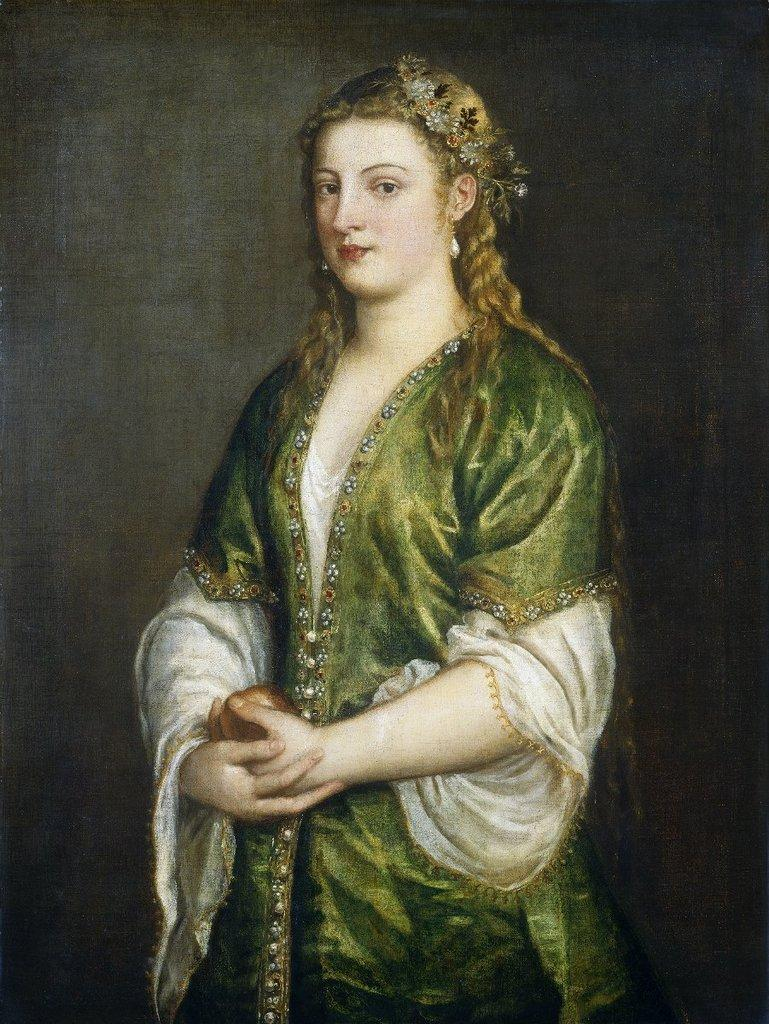What is the main subject of the painting in the image? There is a painting of a woman in the image. What is the woman wearing in the painting? The woman is wearing a green dress in the painting. How would you describe the overall color scheme of the image? The background of the image is dark. What type of insurance policy does the woman in the painting have? There is no information about the woman's insurance policy in the image, as it is a painting of a woman wearing a green dress with a dark background. 